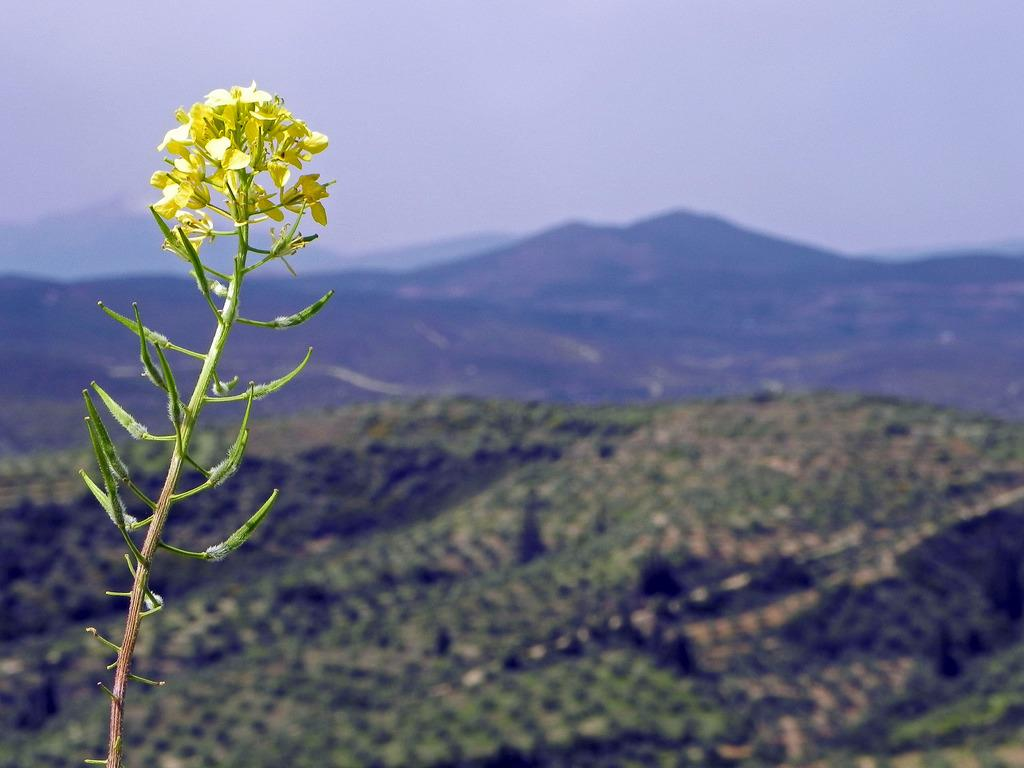What type of vegetation can be seen in the image? There are trees and a plant with flowers in the image. What geographical feature is visible in the image? There are hills visible in the image. What is the condition of the sky in the image? The sky is cloudy in the image. How does the plant control the growth of the flowers in the image? The plant does not control the growth of the flowers in the image; it is a natural process. 